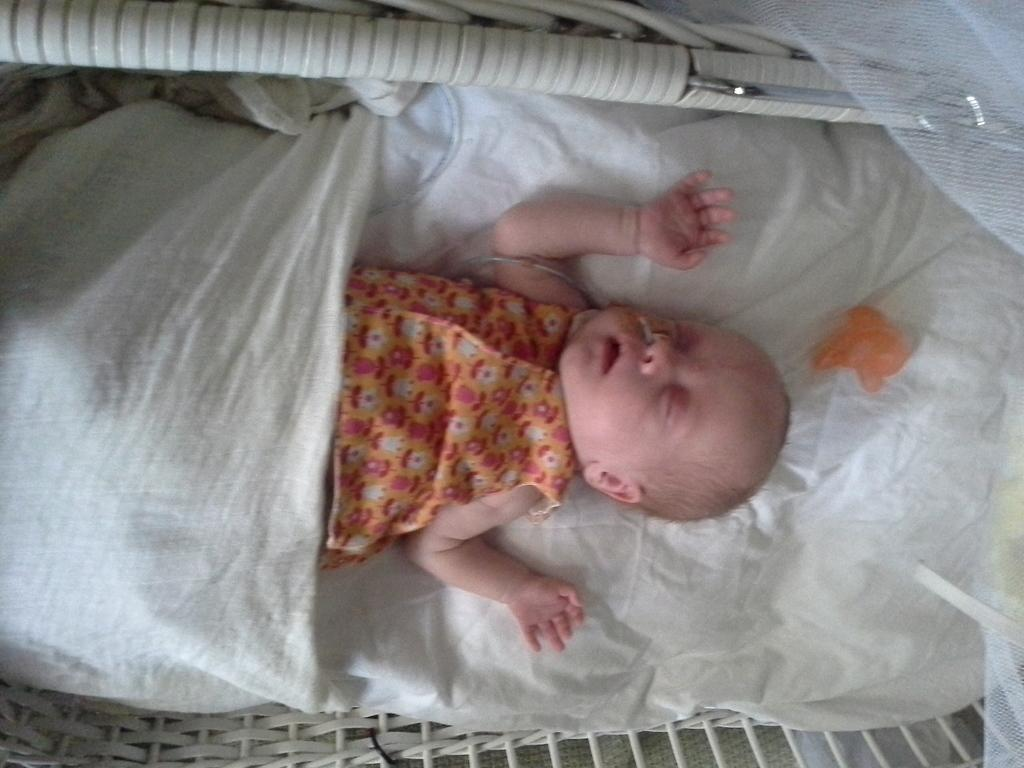What is the main subject of the image? There is a baby in the image. What is the baby doing in the image? The baby is lying on a baby swing. What can be seen in the background of the image? There is cloth and a net visible in the background. How many bombs are visible in the image? There are no bombs present in the image. What type of goose can be seen interacting with the baby in the image? There is no goose present in the image; the baby is lying on a baby swing. 